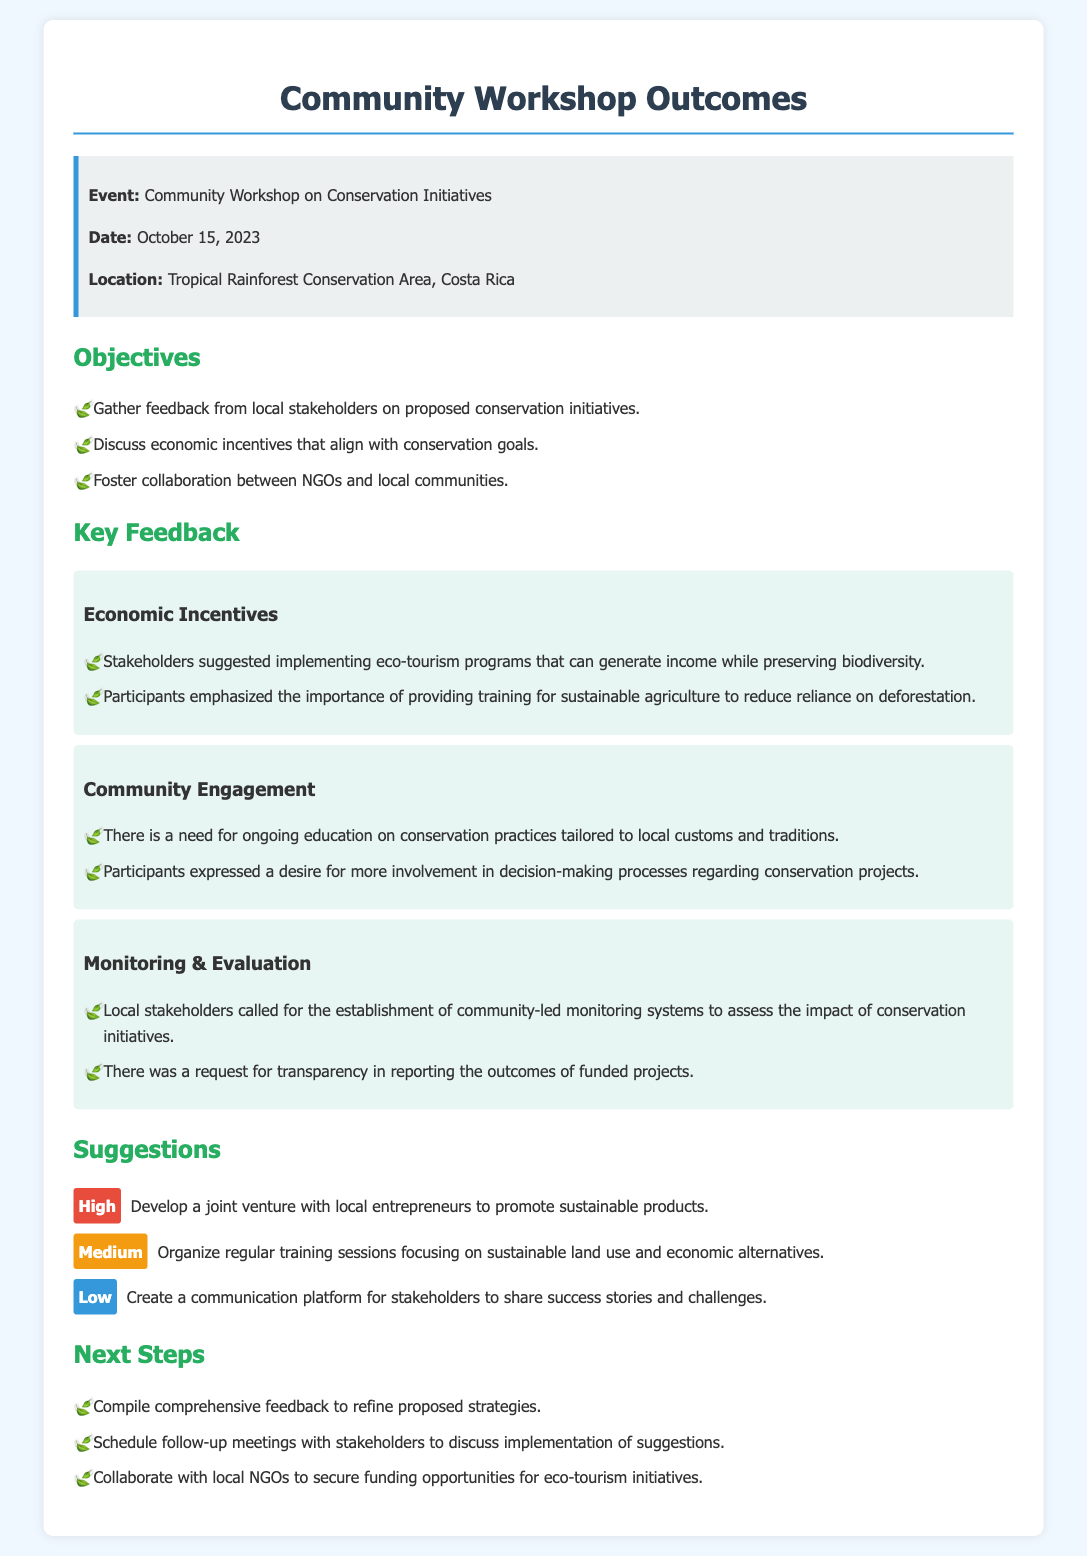What was the date of the workshop? The date is stated clearly in the event details section of the document.
Answer: October 15, 2023 What is one of the suggested economic incentives mentioned? The document lists several feedback items, including suggestions for eco-tourism programs.
Answer: Eco-tourism programs What was emphasized by participants regarding agriculture? Participants stressed the importance of reducing reliance on deforestation through sustainable practices, mentioned in feedback.
Answer: Training for sustainable agriculture What priority level is assigned to developing a joint venture with local entrepreneurs? The priority level is indicated alongside each suggestion, categorizing them as high, medium, or low.
Answer: High Where was the workshop held? The location is provided in the event details section of the document.
Answer: Tropical Rainforest Conservation Area, Costa Rica What do local stakeholders want in terms of monitoring conservation initiatives? The document includes requests from stakeholders about the systems they want for evaluating initiatives.
Answer: Community-led monitoring systems What is one of the next steps mentioned? The next steps section outlines various actions to be taken after the workshop.
Answer: Compile comprehensive feedback What is a key theme regarding community engagement? The document provides feedback from participants about their involvement in decision-making.
Answer: More involvement in decision-making processes What type of platform is suggested for stakeholders to share experiences? Suggestions for communication methods are listed within the document's suggestions section.
Answer: Create a communication platform 